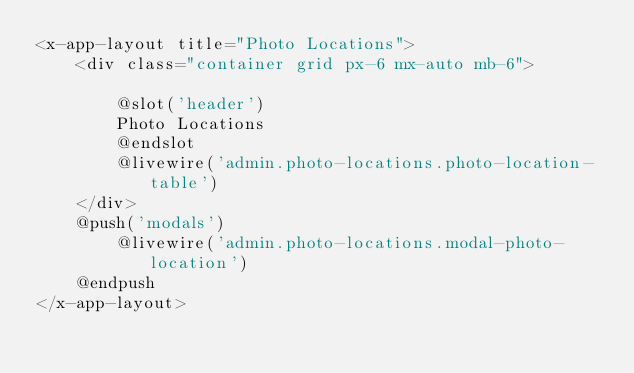<code> <loc_0><loc_0><loc_500><loc_500><_PHP_><x-app-layout title="Photo Locations">
    <div class="container grid px-6 mx-auto mb-6">

        @slot('header')
        Photo Locations
        @endslot
        @livewire('admin.photo-locations.photo-location-table')
    </div>
    @push('modals')
        @livewire('admin.photo-locations.modal-photo-location')
    @endpush
</x-app-layout></code> 